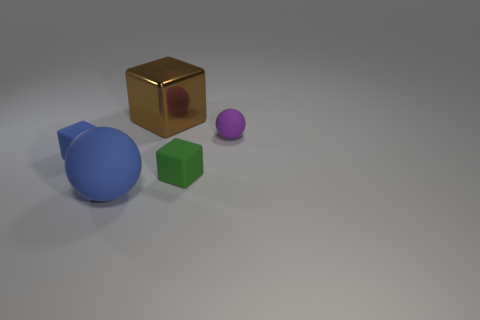Subtract all purple balls. Subtract all purple cylinders. How many balls are left? 1 Add 5 purple matte objects. How many objects exist? 10 Subtract all blocks. How many objects are left? 2 Add 2 small yellow balls. How many small yellow balls exist? 2 Subtract 0 green balls. How many objects are left? 5 Subtract all blocks. Subtract all blue blocks. How many objects are left? 1 Add 5 tiny blue cubes. How many tiny blue cubes are left? 6 